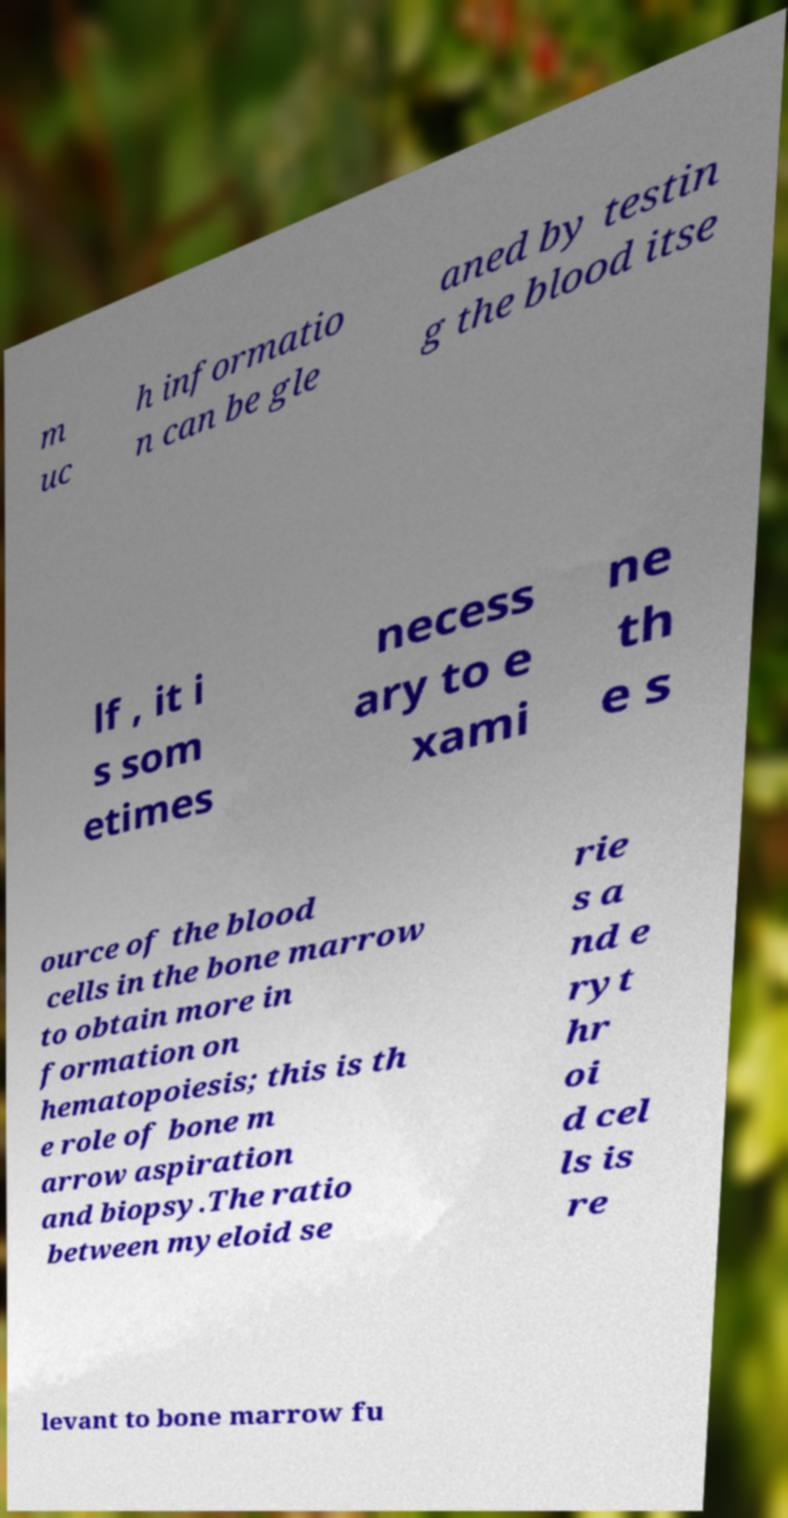Could you assist in decoding the text presented in this image and type it out clearly? m uc h informatio n can be gle aned by testin g the blood itse lf , it i s som etimes necess ary to e xami ne th e s ource of the blood cells in the bone marrow to obtain more in formation on hematopoiesis; this is th e role of bone m arrow aspiration and biopsy.The ratio between myeloid se rie s a nd e ryt hr oi d cel ls is re levant to bone marrow fu 